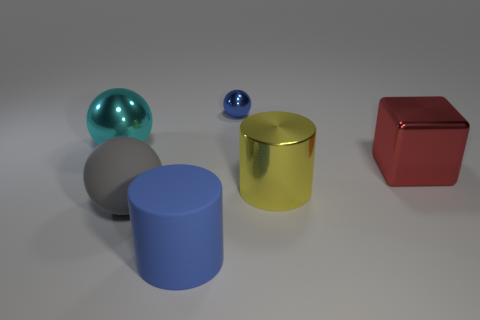Add 2 large shiny things. How many objects exist? 8 Subtract all matte spheres. How many spheres are left? 2 Subtract 1 cubes. How many cubes are left? 0 Subtract all yellow cylinders. How many cylinders are left? 1 Add 1 cylinders. How many cylinders exist? 3 Subtract 0 brown cubes. How many objects are left? 6 Subtract all blocks. How many objects are left? 5 Subtract all blue spheres. Subtract all purple cylinders. How many spheres are left? 2 Subtract all blue blocks. How many purple balls are left? 0 Subtract all yellow metallic objects. Subtract all blue balls. How many objects are left? 4 